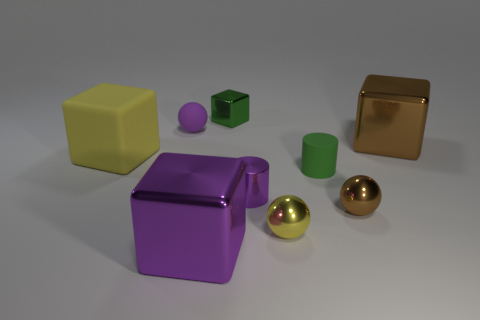Add 1 large brown shiny blocks. How many objects exist? 10 Subtract all yellow shiny spheres. How many spheres are left? 2 Subtract all purple cubes. How many cubes are left? 3 Subtract all cylinders. How many objects are left? 7 Subtract all brown balls. How many green cylinders are left? 1 Add 6 tiny purple cylinders. How many tiny purple cylinders exist? 7 Subtract 1 brown spheres. How many objects are left? 8 Subtract 1 cylinders. How many cylinders are left? 1 Subtract all gray spheres. Subtract all purple cylinders. How many spheres are left? 3 Subtract all small balls. Subtract all tiny green matte cylinders. How many objects are left? 5 